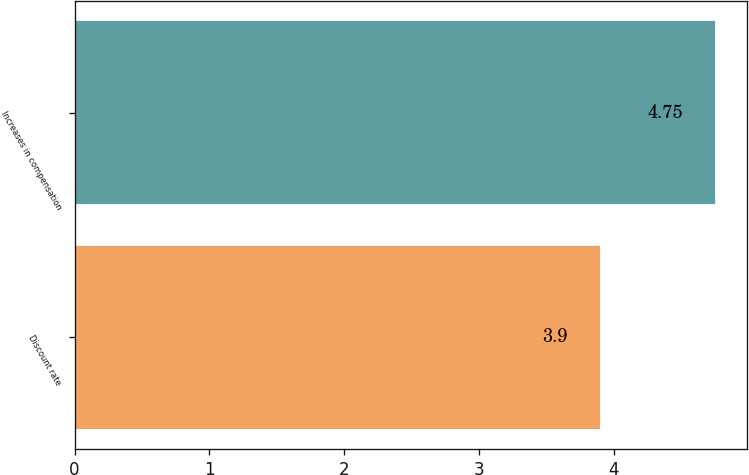Convert chart. <chart><loc_0><loc_0><loc_500><loc_500><bar_chart><fcel>Discount rate<fcel>Increases in compensation<nl><fcel>3.9<fcel>4.75<nl></chart> 